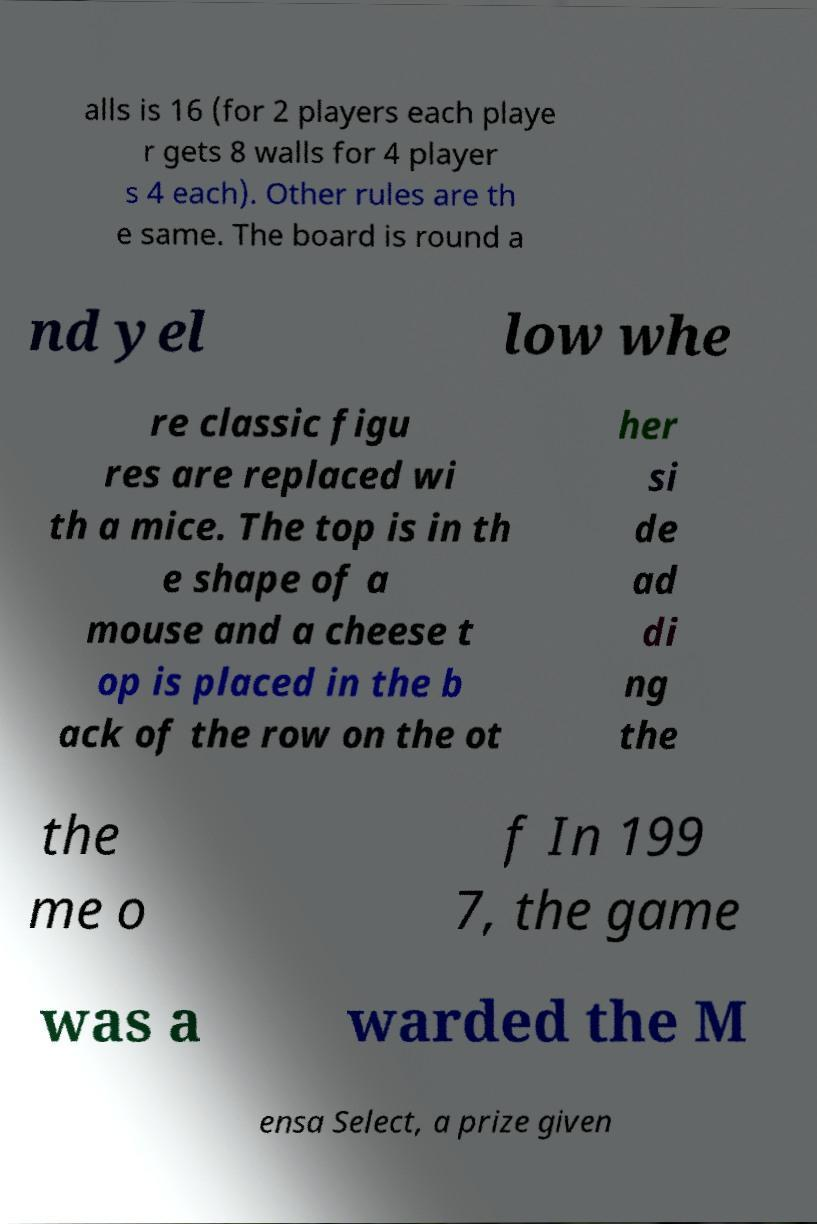Can you accurately transcribe the text from the provided image for me? alls is 16 (for 2 players each playe r gets 8 walls for 4 player s 4 each). Other rules are th e same. The board is round a nd yel low whe re classic figu res are replaced wi th a mice. The top is in th e shape of a mouse and a cheese t op is placed in the b ack of the row on the ot her si de ad di ng the the me o f In 199 7, the game was a warded the M ensa Select, a prize given 